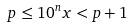<formula> <loc_0><loc_0><loc_500><loc_500>p \leq 1 0 ^ { n } x < p + 1</formula> 